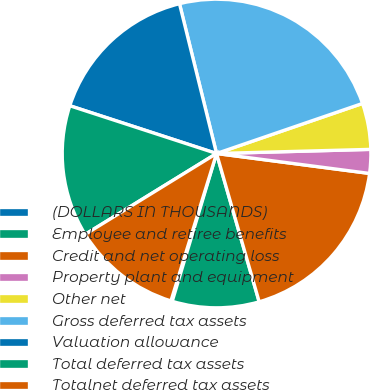Convert chart. <chart><loc_0><loc_0><loc_500><loc_500><pie_chart><fcel>(DOLLARS IN THOUSANDS)<fcel>Employee and retiree benefits<fcel>Credit and net operating loss<fcel>Property plant and equipment<fcel>Other net<fcel>Gross deferred tax assets<fcel>Valuation allowance<fcel>Total deferred tax assets<fcel>Totalnet deferred tax assets<nl><fcel>0.14%<fcel>9.09%<fcel>18.48%<fcel>2.49%<fcel>4.83%<fcel>23.6%<fcel>16.13%<fcel>13.79%<fcel>11.44%<nl></chart> 